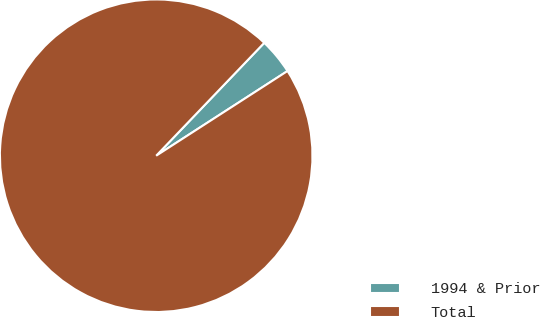<chart> <loc_0><loc_0><loc_500><loc_500><pie_chart><fcel>1994 & Prior<fcel>Total<nl><fcel>3.73%<fcel>96.27%<nl></chart> 